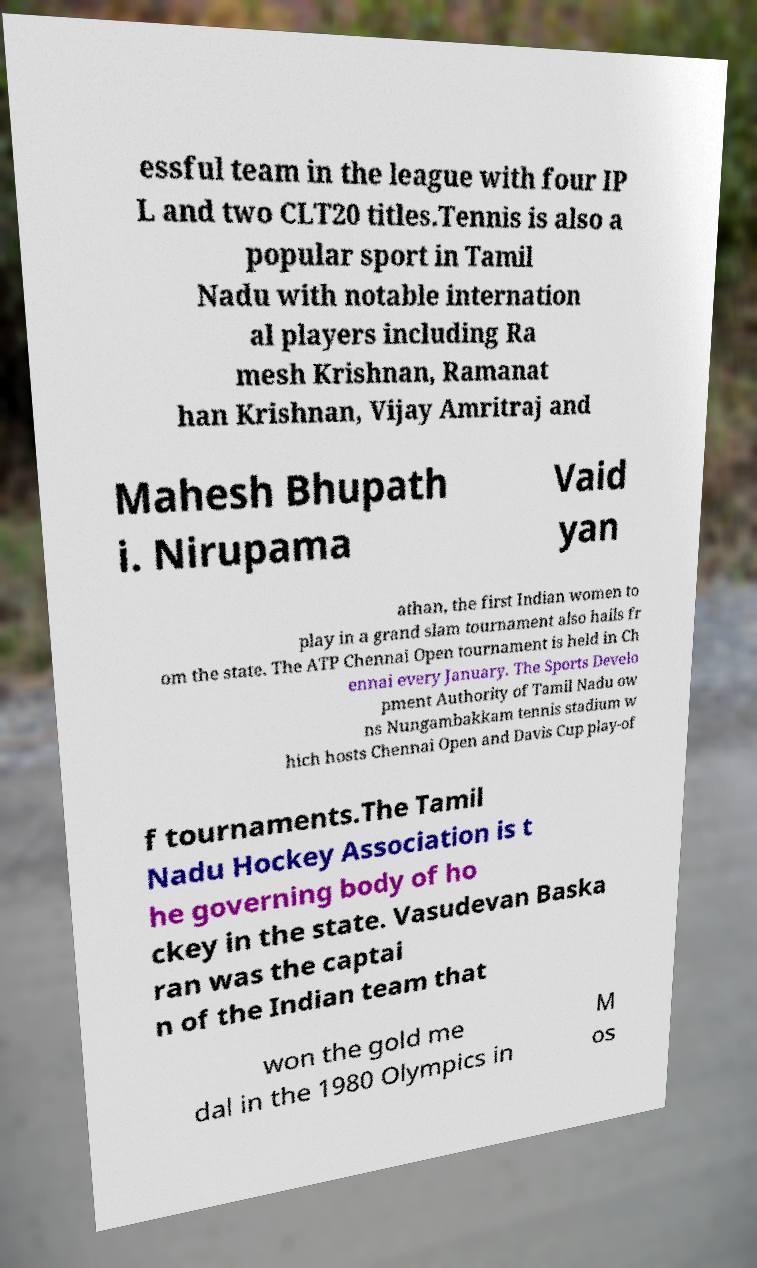I need the written content from this picture converted into text. Can you do that? essful team in the league with four IP L and two CLT20 titles.Tennis is also a popular sport in Tamil Nadu with notable internation al players including Ra mesh Krishnan, Ramanat han Krishnan, Vijay Amritraj and Mahesh Bhupath i. Nirupama Vaid yan athan, the first Indian women to play in a grand slam tournament also hails fr om the state. The ATP Chennai Open tournament is held in Ch ennai every January. The Sports Develo pment Authority of Tamil Nadu ow ns Nungambakkam tennis stadium w hich hosts Chennai Open and Davis Cup play-of f tournaments.The Tamil Nadu Hockey Association is t he governing body of ho ckey in the state. Vasudevan Baska ran was the captai n of the Indian team that won the gold me dal in the 1980 Olympics in M os 